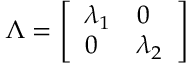<formula> <loc_0><loc_0><loc_500><loc_500>\Lambda = \left [ \begin{array} { l l } { \lambda _ { 1 } } & { 0 } \\ { 0 } & { \lambda _ { 2 } } \end{array} \right ]</formula> 